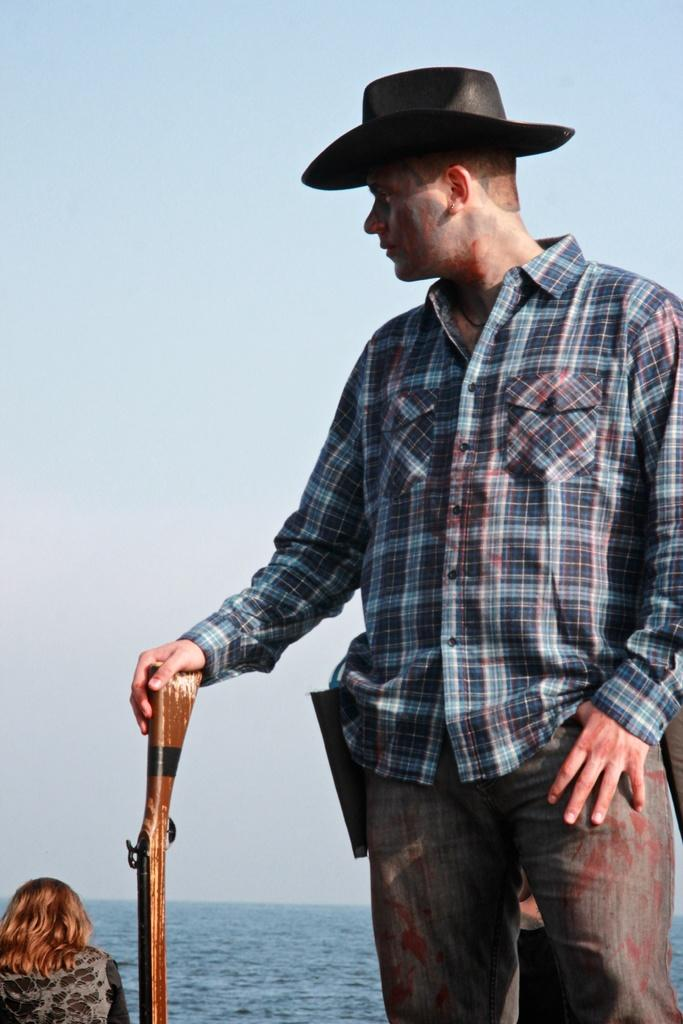What is the main subject of the image? There is a man in the image. Can you describe the man's attire? The man is wearing a cap. What is the man holding in the image? The man is holding a gun. Where is the woman located in the image? The woman is in the lower left part of the image. What can be seen in the background of the image? There is water visible in the background of the image. What type of bells can be heard ringing in the image? There are no bells present in the image, and therefore no sound can be heard. How does the man use the brake in the image? There is no brake present in the image; the man is holding a gun. 